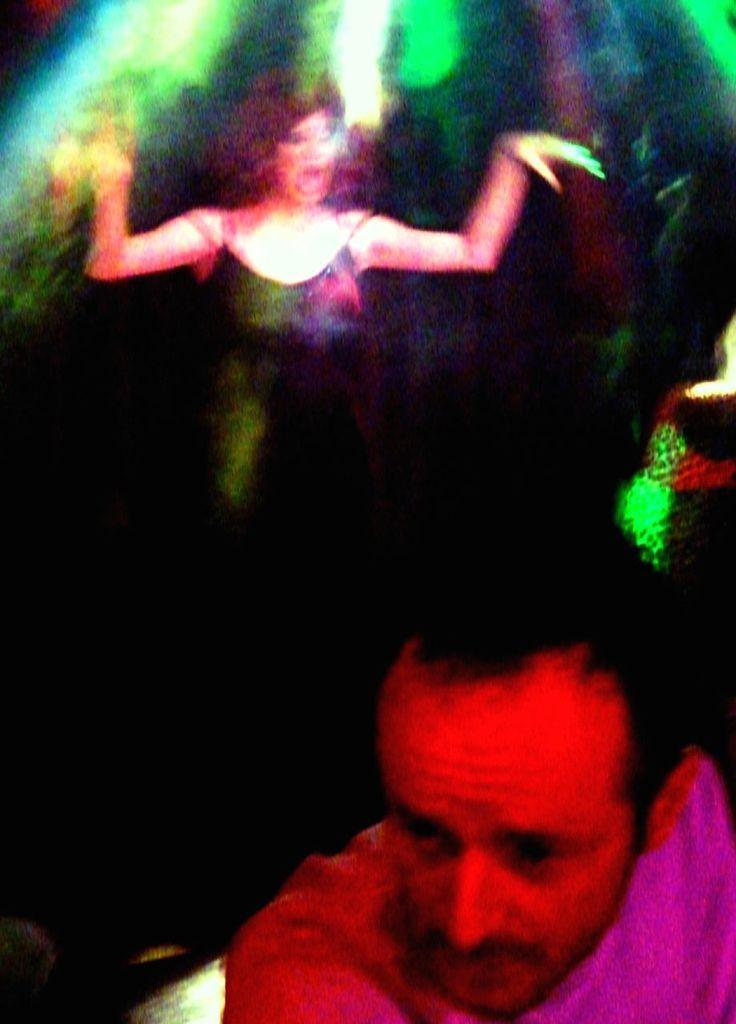Describe this image in one or two sentences. This image is taken indoors. In this image the background is a little blurred. There are a few lights. There is a woman. At the bottom of the image there is a man. 